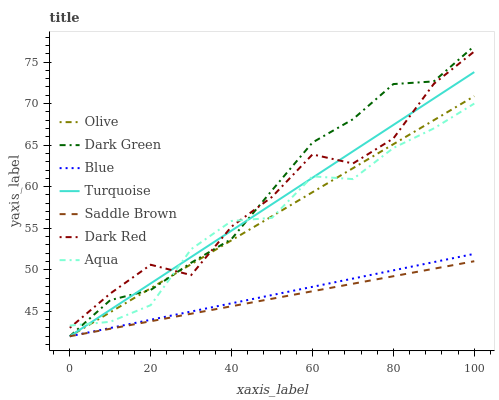Does Saddle Brown have the minimum area under the curve?
Answer yes or no. Yes. Does Dark Green have the maximum area under the curve?
Answer yes or no. Yes. Does Turquoise have the minimum area under the curve?
Answer yes or no. No. Does Turquoise have the maximum area under the curve?
Answer yes or no. No. Is Blue the smoothest?
Answer yes or no. Yes. Is Dark Red the roughest?
Answer yes or no. Yes. Is Turquoise the smoothest?
Answer yes or no. No. Is Turquoise the roughest?
Answer yes or no. No. Does Dark Red have the lowest value?
Answer yes or no. No. Does Dark Green have the highest value?
Answer yes or no. Yes. Does Turquoise have the highest value?
Answer yes or no. No. Is Blue less than Dark Red?
Answer yes or no. Yes. Is Dark Red greater than Blue?
Answer yes or no. Yes. Does Blue intersect Dark Red?
Answer yes or no. No. 